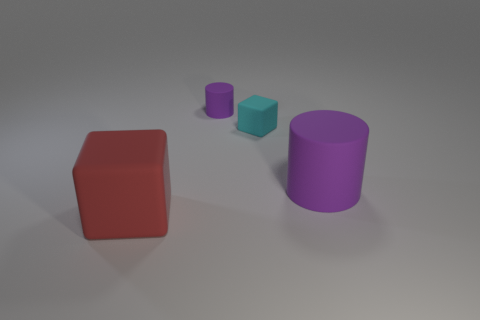Add 3 big rubber objects. How many objects exist? 7 Add 1 matte cubes. How many matte cubes are left? 3 Add 2 big purple objects. How many big purple objects exist? 3 Subtract 0 cyan cylinders. How many objects are left? 4 Subtract all gray things. Subtract all small purple matte cylinders. How many objects are left? 3 